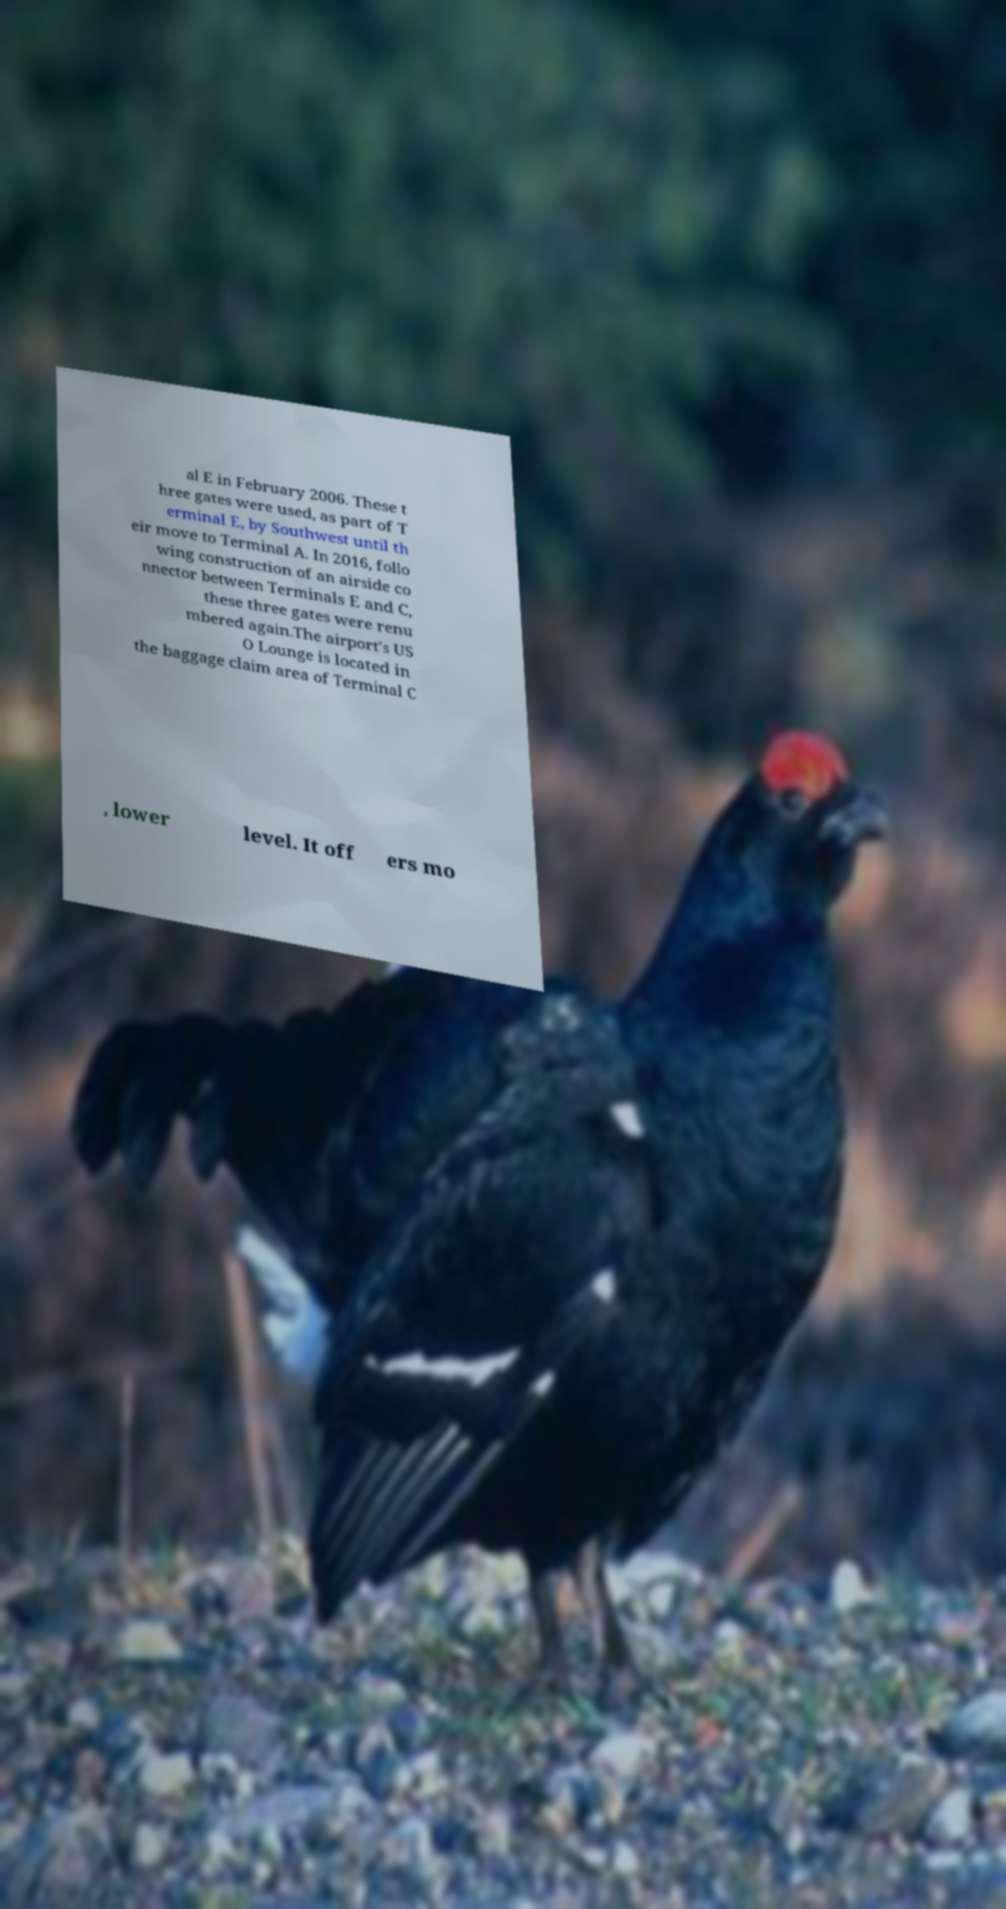Please read and relay the text visible in this image. What does it say? al E in February 2006. These t hree gates were used, as part of T erminal E, by Southwest until th eir move to Terminal A. In 2016, follo wing construction of an airside co nnector between Terminals E and C, these three gates were renu mbered again.The airport's US O Lounge is located in the baggage claim area of Terminal C , lower level. It off ers mo 